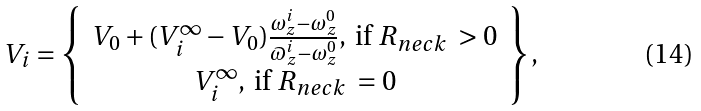<formula> <loc_0><loc_0><loc_500><loc_500>V _ { i } = \left \{ \begin{array} { c } V _ { 0 } + ( V _ { i } ^ { \infty } - V _ { 0 } ) \frac { \omega _ { z } ^ { i } - \omega _ { z } ^ { 0 } } { \varpi _ { z } ^ { i } - \omega _ { z } ^ { 0 } } , \text { if } R _ { n e c k } \text { } > 0 \\ V _ { i } ^ { \infty } , \text { if } R _ { n e c k } \text { } = 0 \end{array} \right \} ,</formula> 